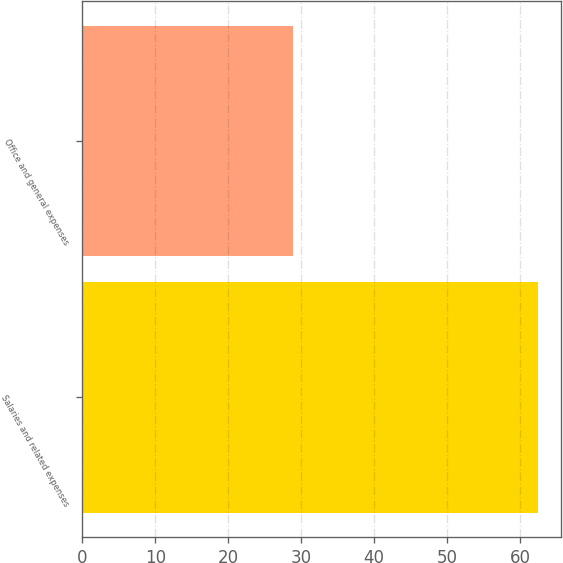Convert chart. <chart><loc_0><loc_0><loc_500><loc_500><bar_chart><fcel>Salaries and related expenses<fcel>Office and general expenses<nl><fcel>62.4<fcel>28.9<nl></chart> 